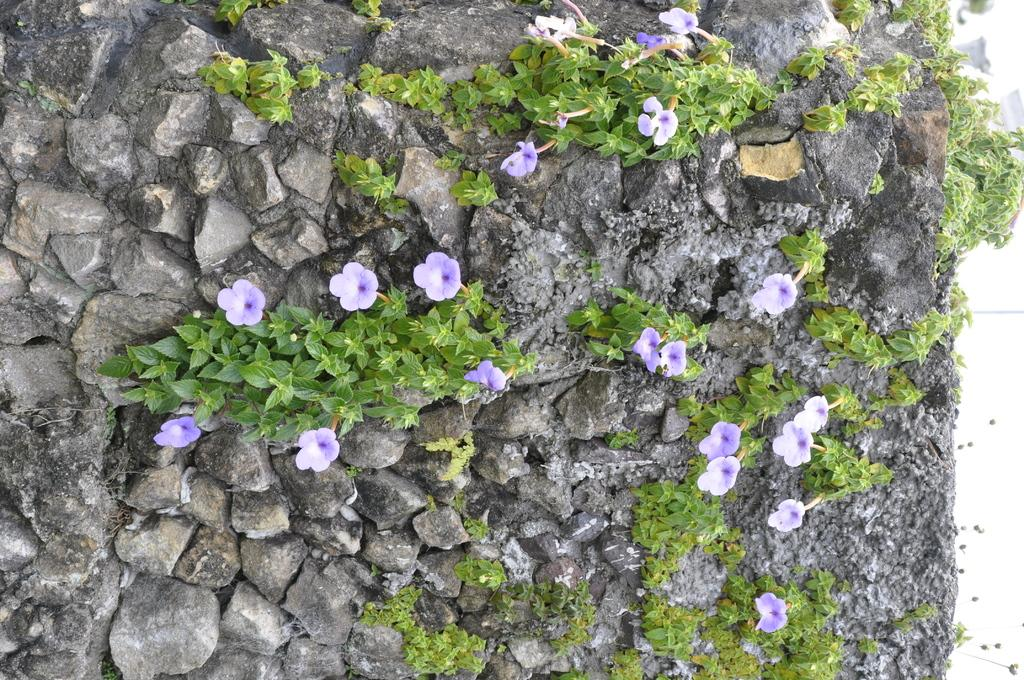Where was the image taken? The image was taken outdoors. What can be seen in the image besides the outdoor setting? There are many rocks and creepers with stems, green leaves, and lilac flowers in the image. What is the color of the flowers in the image? The flowers in the image are lilac in color. What is the title of the carriage in the image? There is no carriage present in the image. Can you describe the taste of the flowers in the image? Flowers do not have a taste, so this question cannot be answered. 